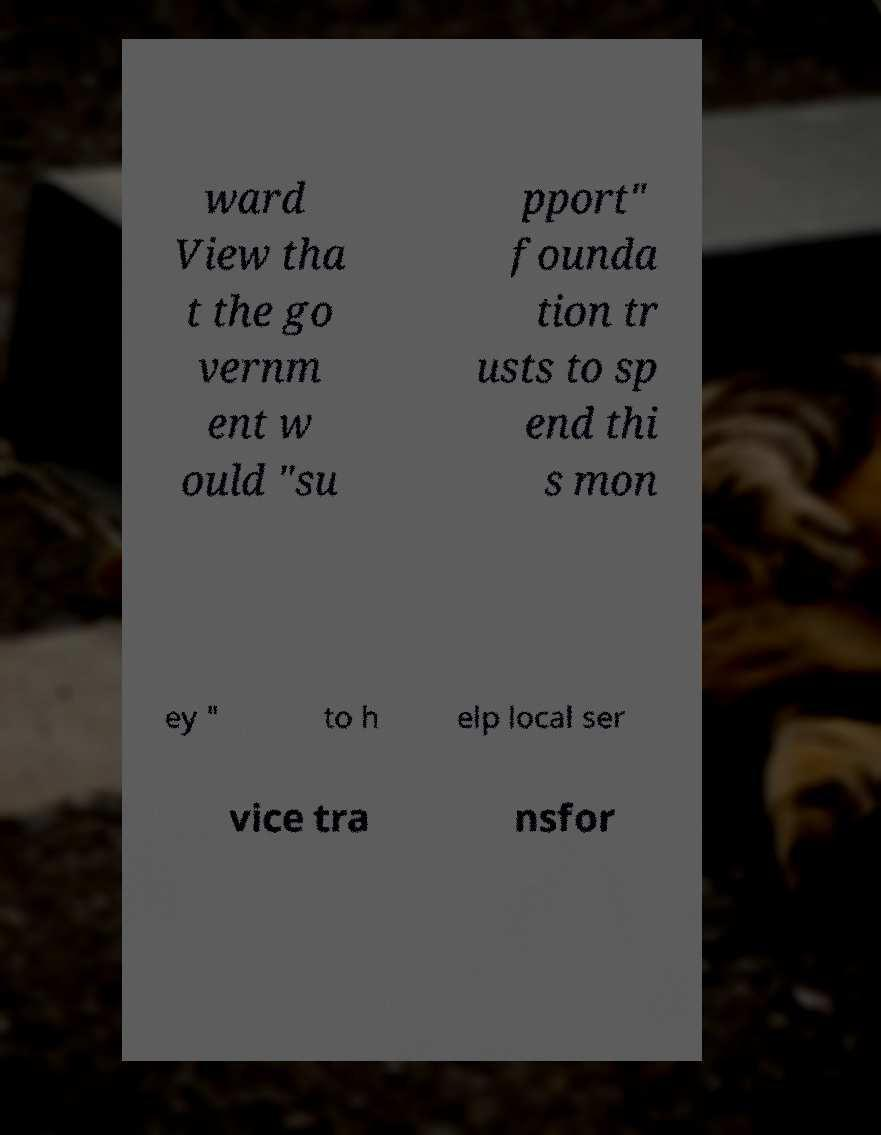Could you assist in decoding the text presented in this image and type it out clearly? ward View tha t the go vernm ent w ould "su pport" founda tion tr usts to sp end thi s mon ey " to h elp local ser vice tra nsfor 